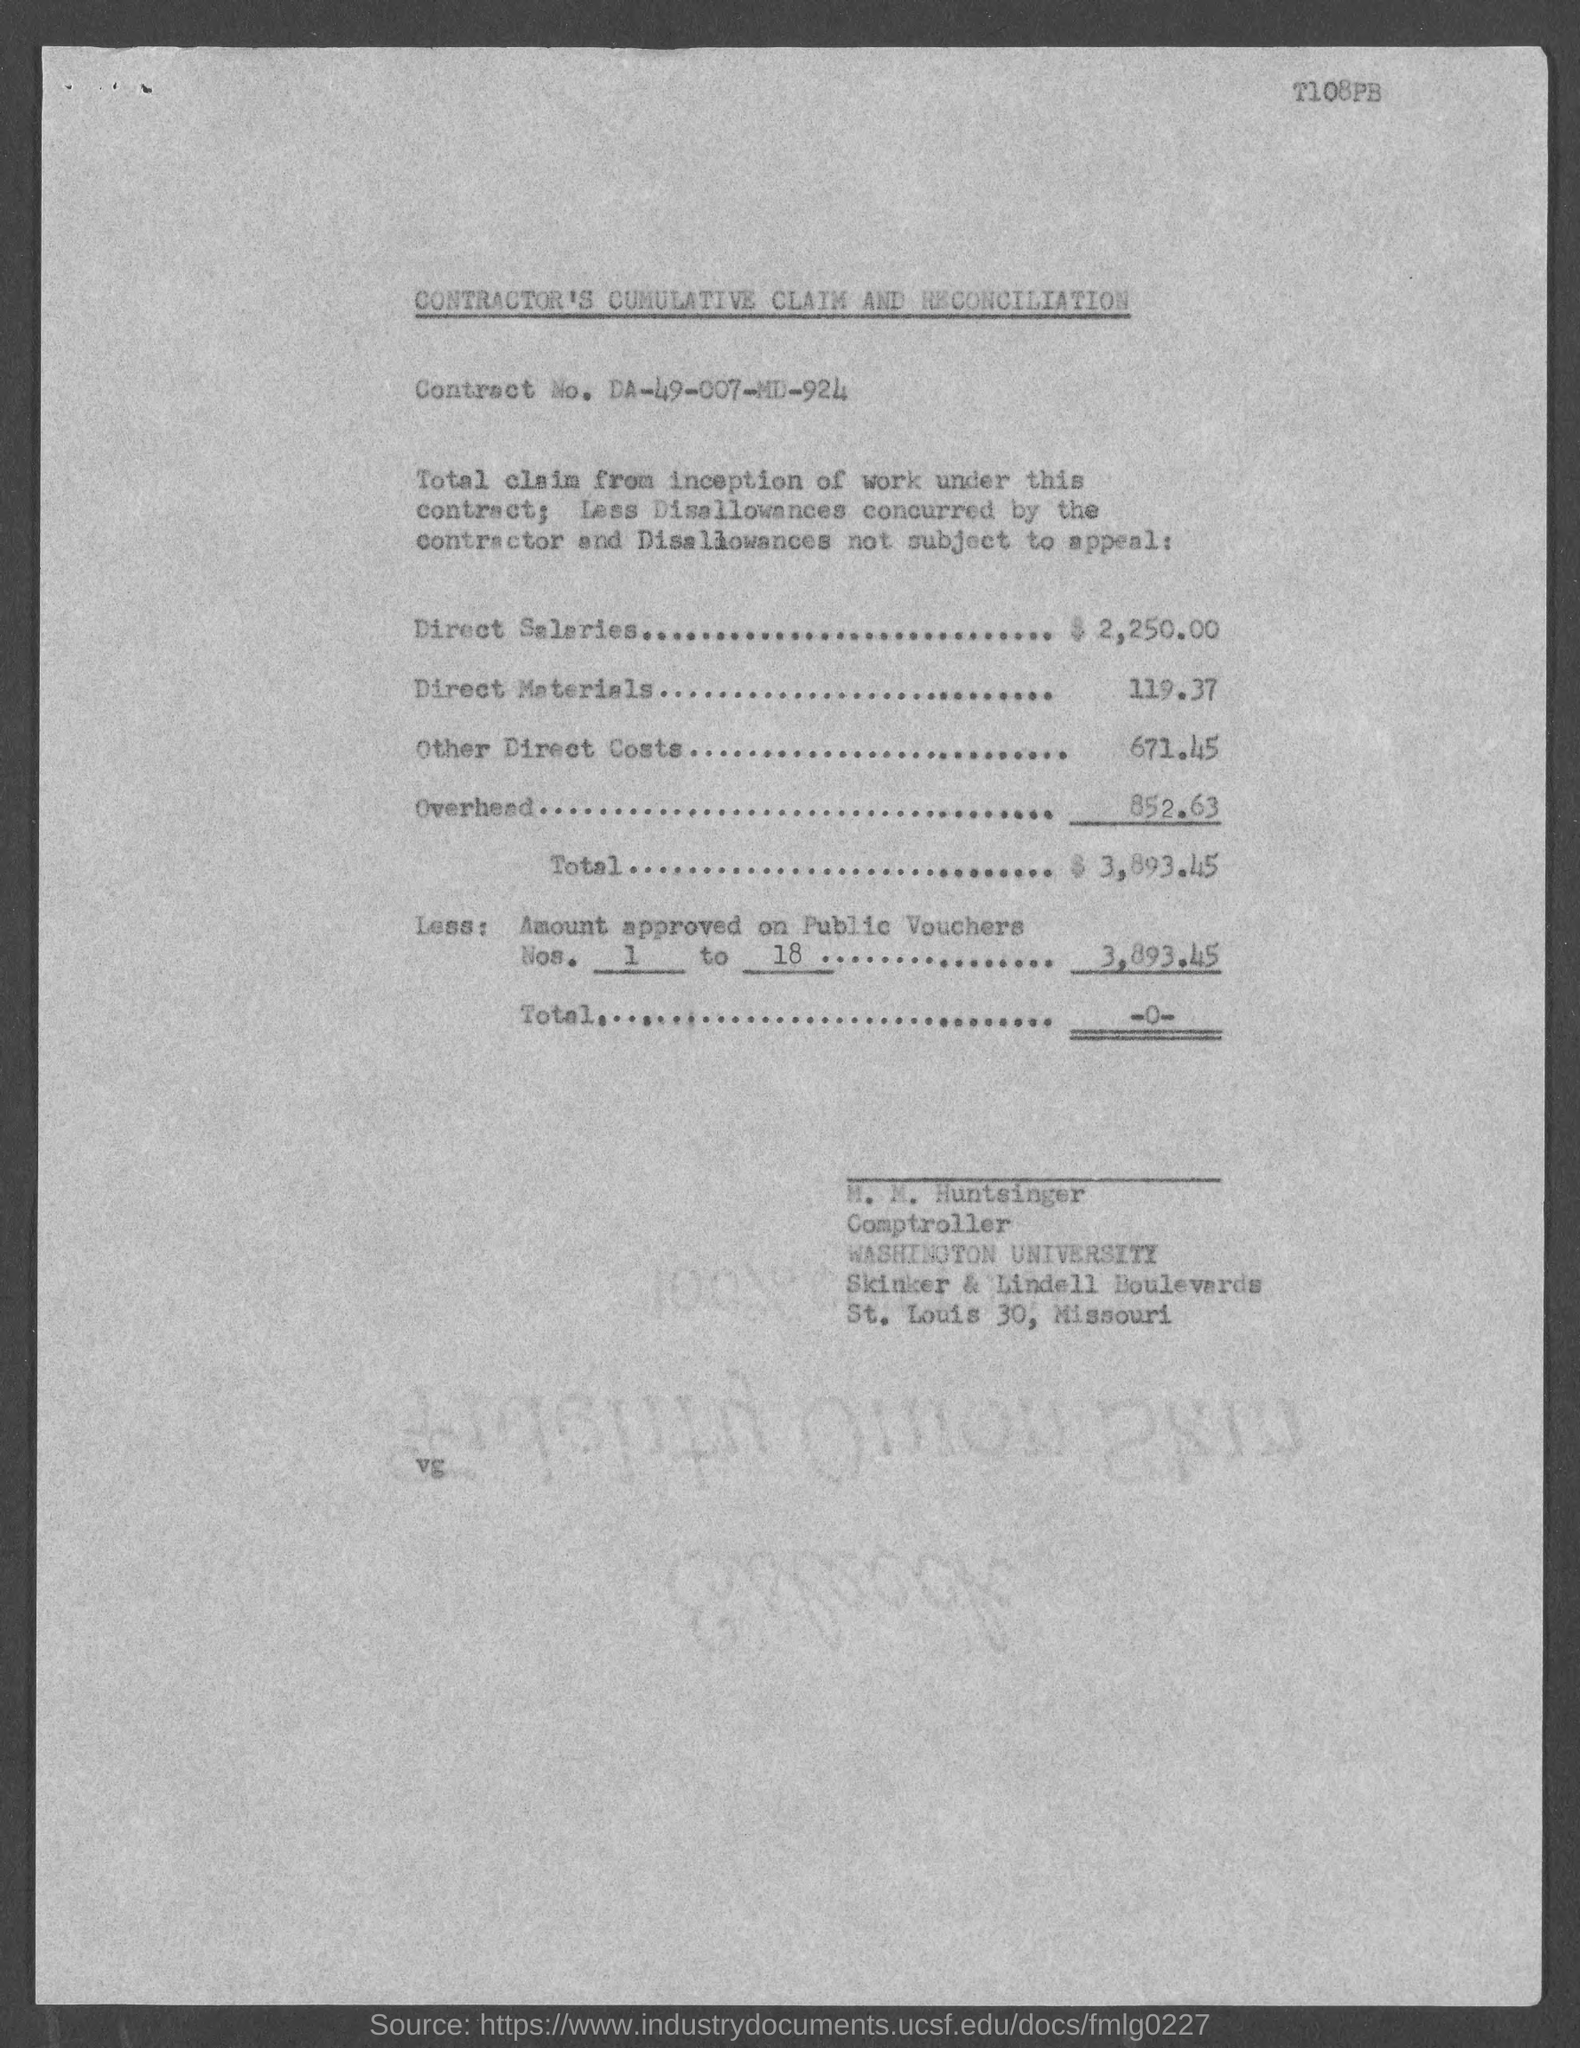Specify some key components in this picture. The document in question is titled "Contractor's Cumulative Claim and Reconciliation. The Comptroller is M.M. Huntsinger. The code mentioned at the top of the page is T108PB... The amount of direct salaries is 2,250.00. The contract number is DA-49-007-MD-924. 